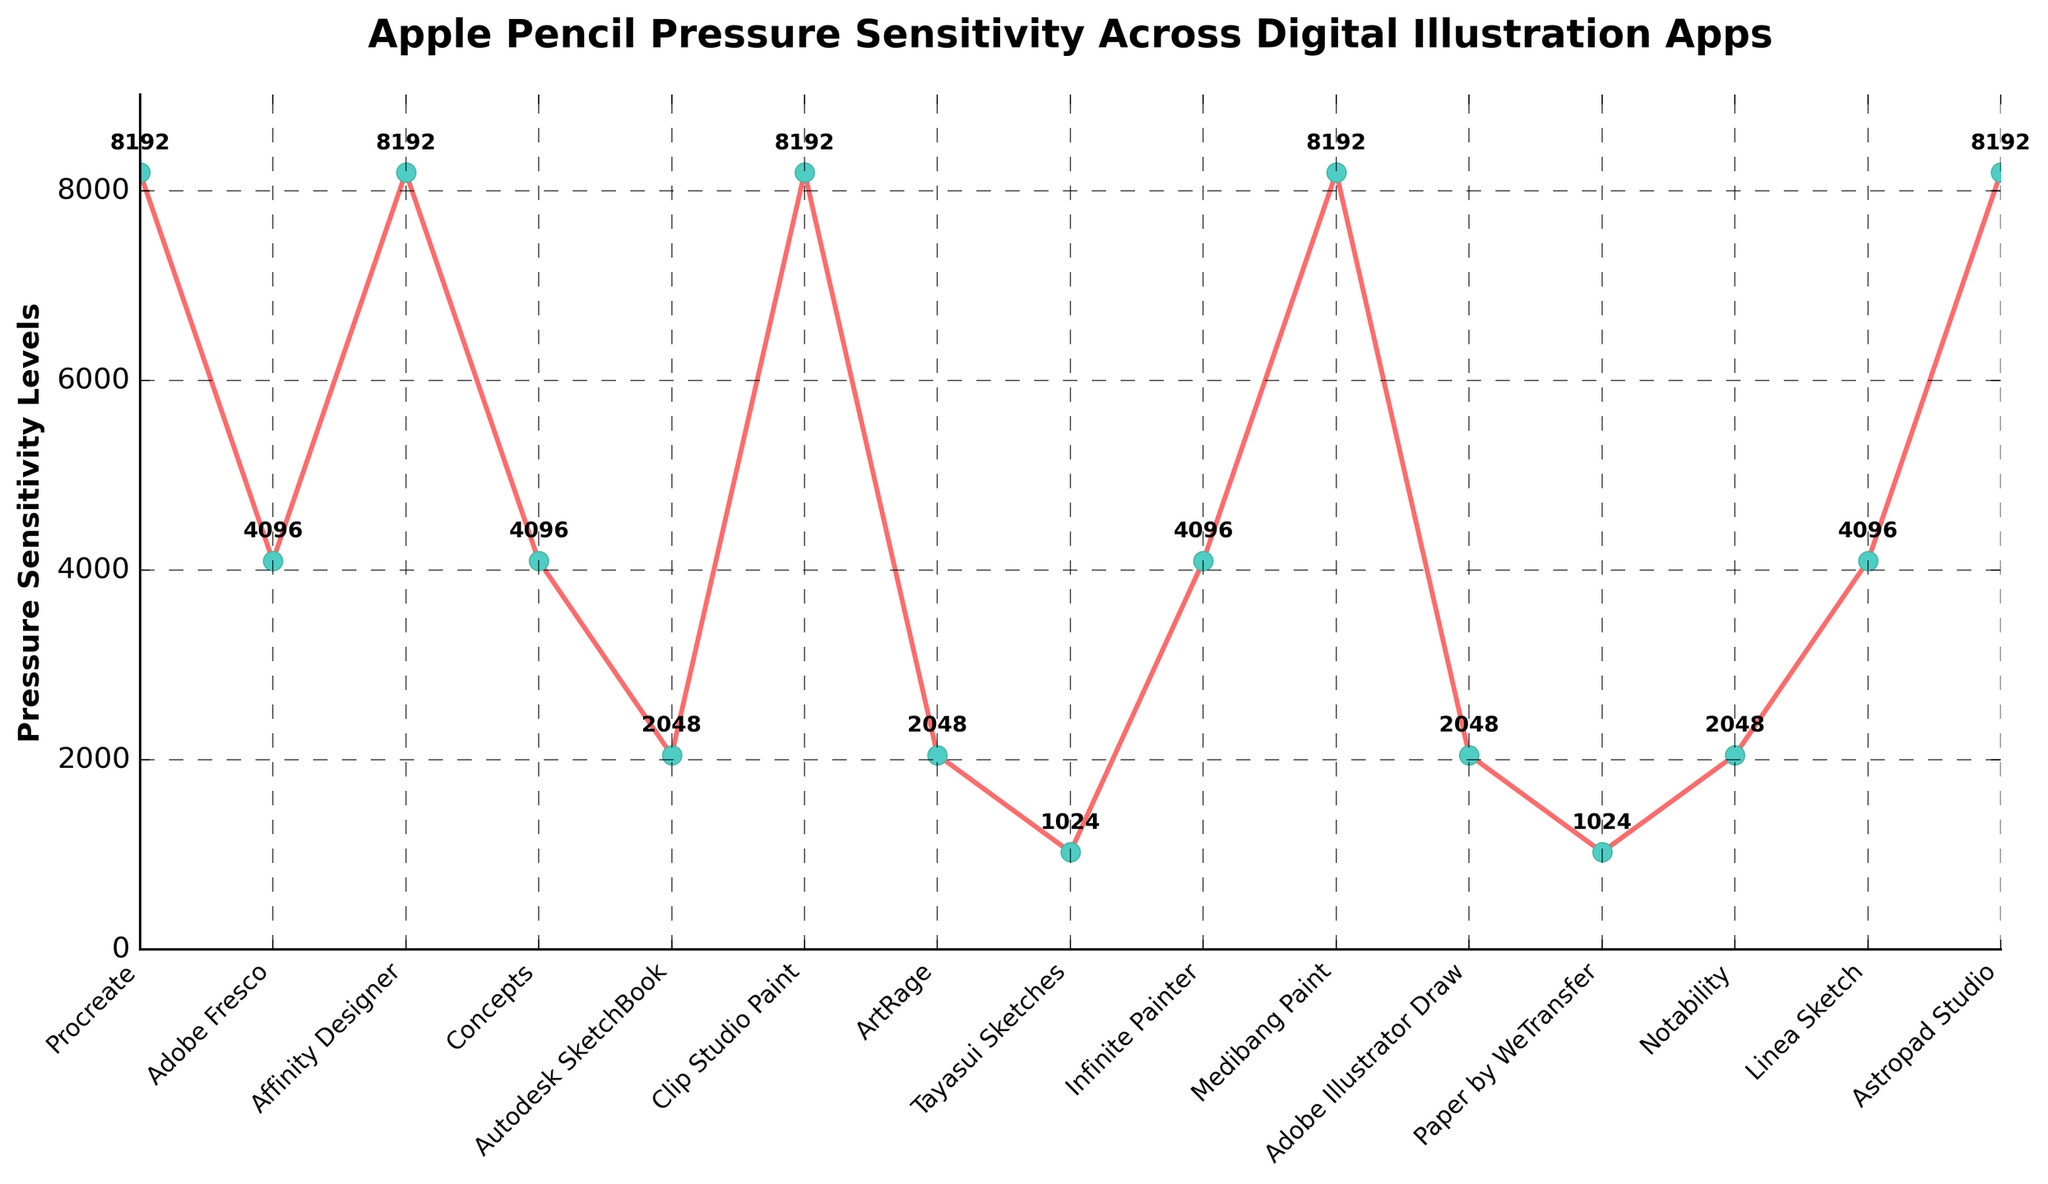What is the highest pressure sensitivity level among the apps? The line chart shows the highest pressure sensitivity level for Procreate, Affinity Designer, Clip Studio Paint, Medibang Paint, and Astropad Studio, each reaching 8192 levels.
Answer: 8192 Which app has the lowest pressure sensitivity level? The lowest pressure sensitivity level is 1024, visible at two points on the line chart, which correspond to Tayasui Sketches and Paper by WeTransfer.
Answer: Tayasui Sketches, Paper by WeTransfer How many apps have a pressure sensitivity level of 4096? There are four points on the chart that have a pressure sensitivity level of 4096, corresponding to Adobe Fresco, Concepts, Infinite Painter, and Linea Sketch.
Answer: 4 Are there any apps with identical pressure sensitivity levels? The chart shows several apps with the same pressure sensitivity levels. For instance, Procreate, Affinity Designer, Clip Studio Paint, Medibang Paint, and Astropad Studio all have 8192 levels. Adobe Fresco, Concepts, Infinite Painter, and Linea Sketch each have 4096 levels. Autodesk SketchBook, ArtRage, Adobe Illustrator Draw, and Notability all have 2048 levels.
Answer: Yes Which app has the highest pressure sensitivity level after Procreate? The pressure sensitivity level for various apps listed at the maximum of 8192 include Affinity Designer, Clip Studio Paint, Medibang Paint, and Astropad Studio, which is the same as Procreate.
Answer: Affinity Designer, Clip Studio Paint, Medibang Paint, Astropad Studio What is the difference in pressure sensitivity levels between the app with the highest and the app with the lowest levels? The highest pressure sensitivity level is 8192, and the lowest is 1024. The difference is calculated as 8192 - 1024 = 7168.
Answer: 7168 What is the average pressure sensitivity level across all apps? Sum the pressure sensitivity levels for all 15 apps: 8192 + 4096 + 8192 + 4096 + 2048 + 8192 + 2048 + 1024 + 4096 + 8192 + 2048 + 1024 + 2048 + 4096 + 8192 = 68512. Average = 68512 / 15 ≈ 4567
Answer: 4567 Which app's pressure sensitivity level is closest to the average level across all apps? The average calculated is 4567. Comparing the pressure sensitivity levels of each app to this value, Adobe Fresco, Concepts, Infinite Painter, and Linea Sketch each have the level of 4096, which is closest to the average.
Answer: Adobe Fresco, Concepts, Infinite Painter, Linea Sketch 